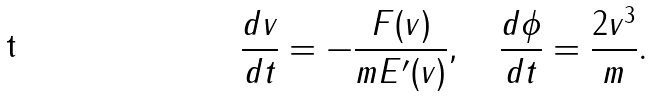<formula> <loc_0><loc_0><loc_500><loc_500>\frac { d v } { d t } = - \frac { F ( v ) } { m E ^ { \prime } ( v ) } , \quad \frac { d \phi } { d t } = \frac { 2 v ^ { 3 } } { m } .</formula> 